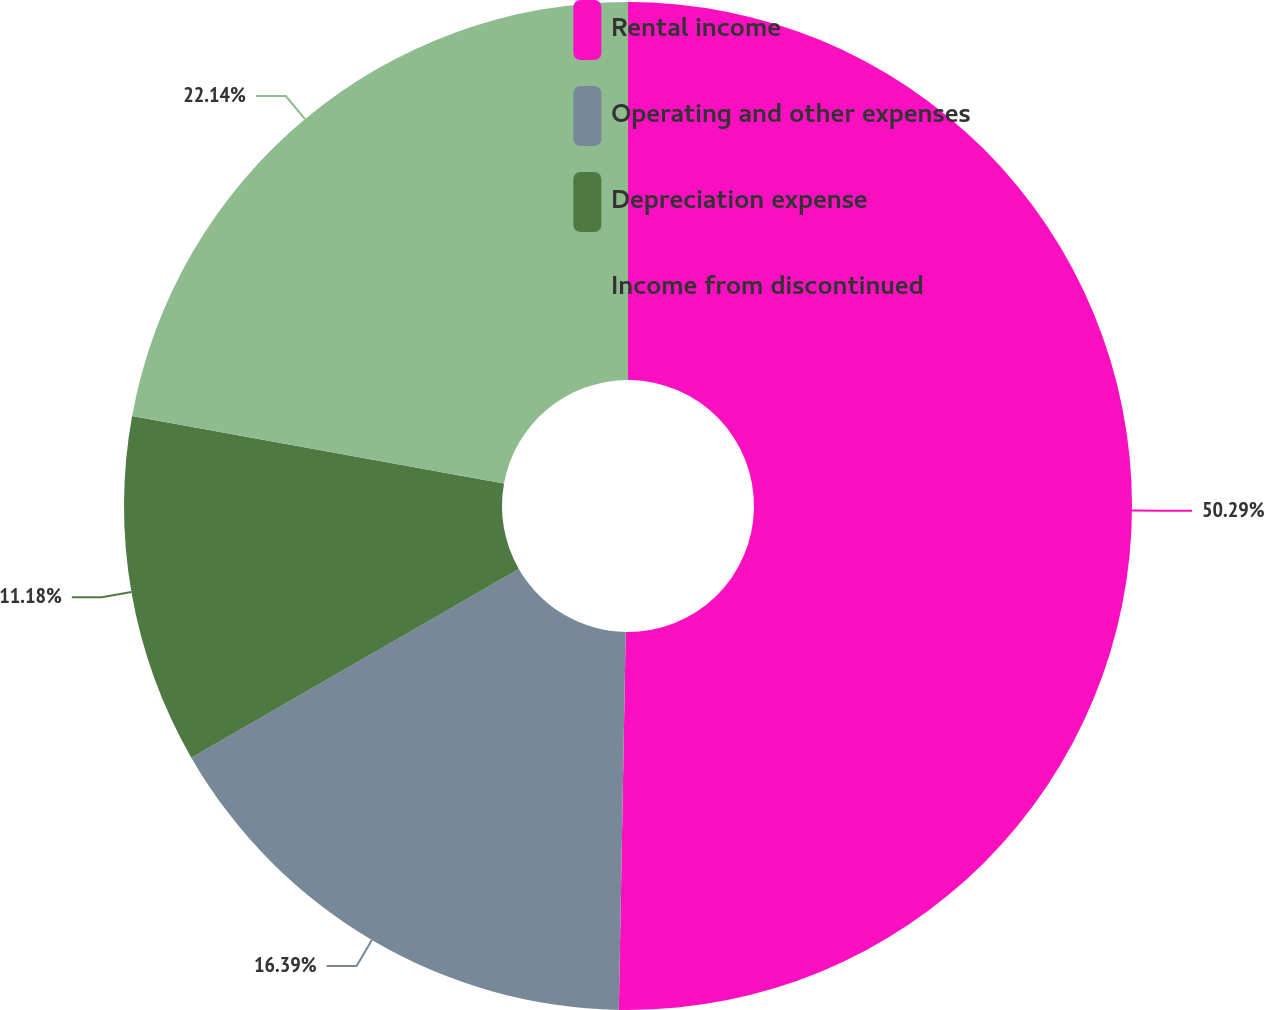Convert chart. <chart><loc_0><loc_0><loc_500><loc_500><pie_chart><fcel>Rental income<fcel>Operating and other expenses<fcel>Depreciation expense<fcel>Income from discontinued<nl><fcel>50.29%<fcel>16.39%<fcel>11.18%<fcel>22.14%<nl></chart> 